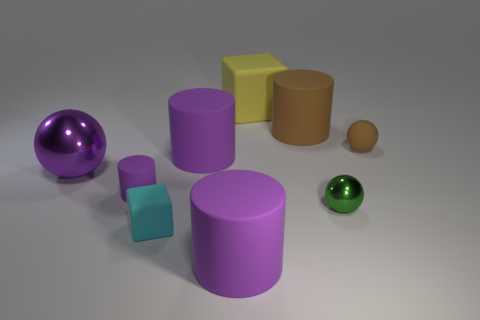Are there any red objects of the same size as the brown sphere?
Give a very brief answer. No. There is a big thing that is to the left of the small matte cube; what material is it?
Provide a succinct answer. Metal. There is a tiny cylinder that is the same material as the small brown object; what color is it?
Your answer should be very brief. Purple. What number of metallic objects are brown spheres or cyan objects?
Keep it short and to the point. 0. There is a brown rubber object that is the same size as the purple metal ball; what shape is it?
Keep it short and to the point. Cylinder. How many things are either tiny objects that are to the right of the small cyan rubber cube or purple spheres that are behind the small green ball?
Your response must be concise. 3. There is a cylinder that is the same size as the brown sphere; what material is it?
Your response must be concise. Rubber. What number of other things are the same material as the big yellow block?
Your response must be concise. 6. Are there an equal number of matte blocks left of the brown cylinder and big matte blocks that are in front of the small brown rubber object?
Your answer should be compact. No. What number of purple things are tiny balls or big rubber blocks?
Give a very brief answer. 0. 